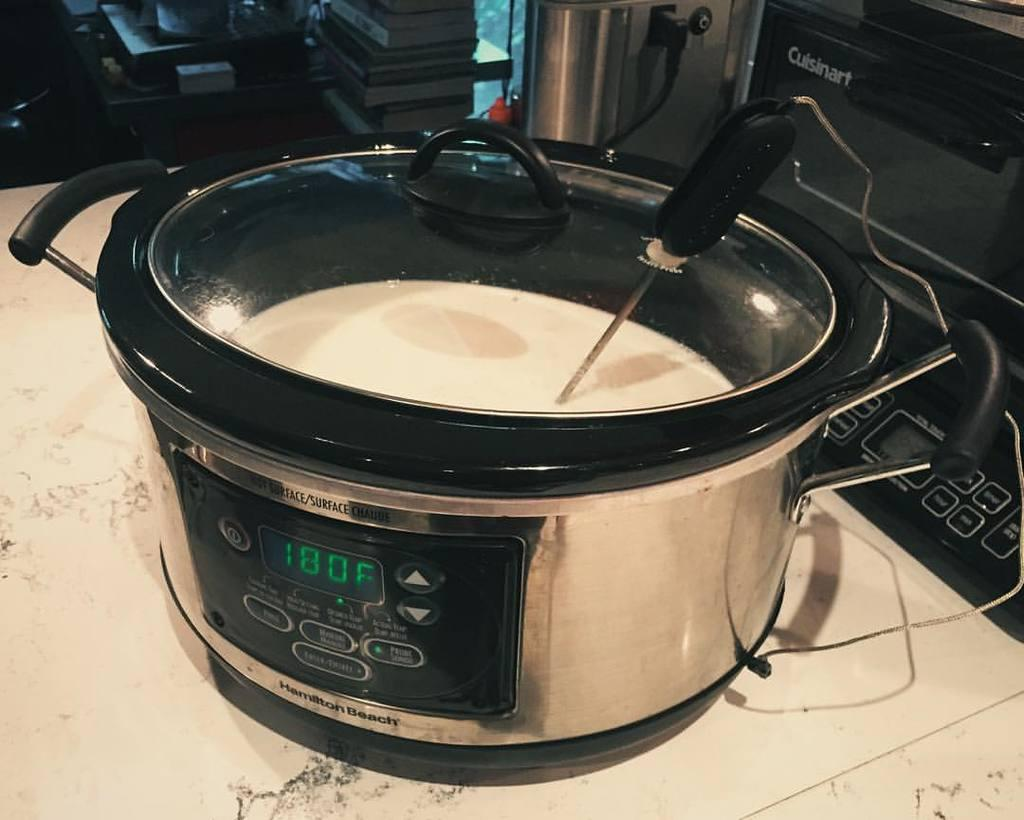<image>
Present a compact description of the photo's key features. A crockpot with a liquid inside which is set to 180 degrees. 